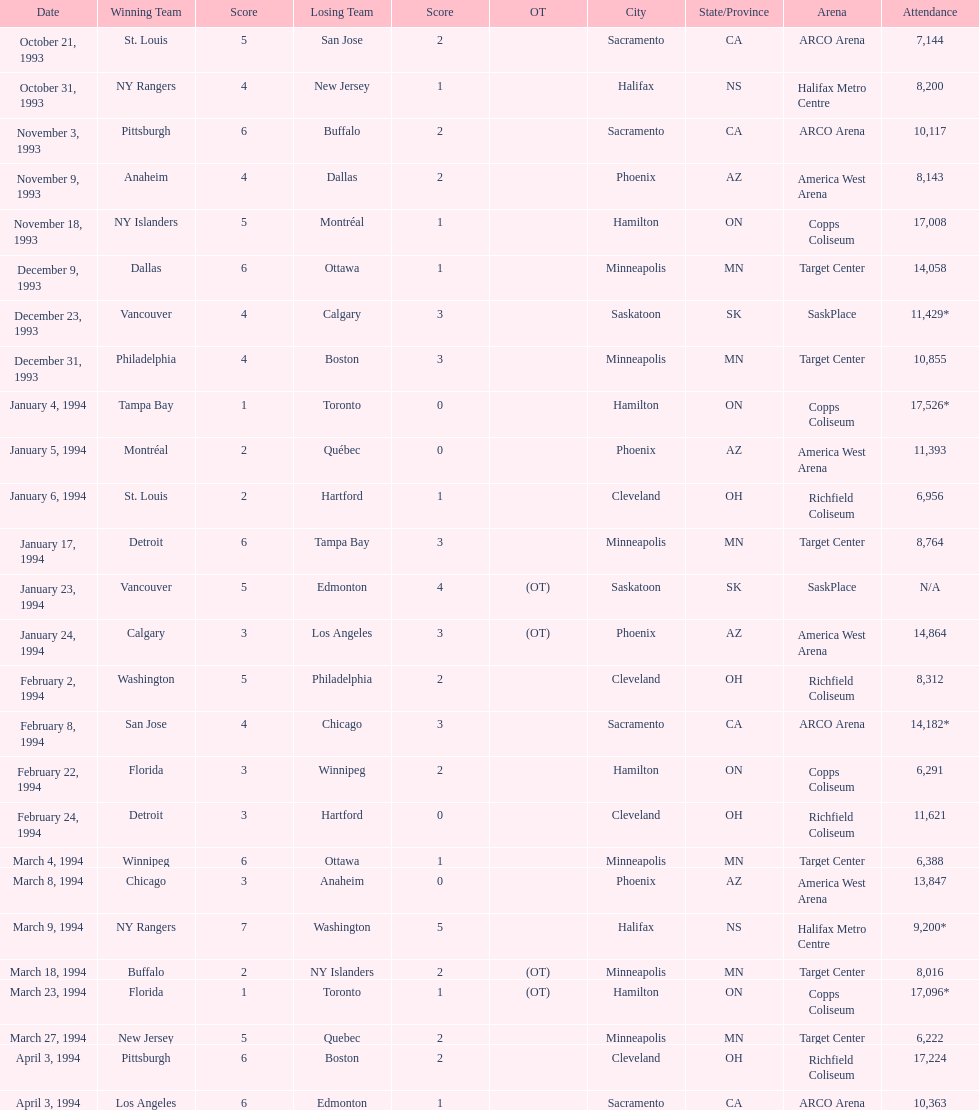When were the events conducted? October 21, 1993, October 31, 1993, November 3, 1993, November 9, 1993, November 18, 1993, December 9, 1993, December 23, 1993, December 31, 1993, January 4, 1994, January 5, 1994, January 6, 1994, January 17, 1994, January 23, 1994, January 24, 1994, February 2, 1994, February 8, 1994, February 22, 1994, February 24, 1994, March 4, 1994, March 8, 1994, March 9, 1994, March 18, 1994, March 23, 1994, March 27, 1994, April 3, 1994, April 3, 1994. What was the number of people present for those events? 7,144, 8,200, 10,117, 8,143, 17,008, 14,058, 11,429*, 10,855, 17,526*, 11,393, 6,956, 8,764, N/A, 14,864, 8,312, 14,182*, 6,291, 11,621, 6,388, 13,847, 9,200*, 8,016, 17,096*, 6,222, 17,224, 10,363. On which date was the highest number of people in attendance? January 4, 1994. 